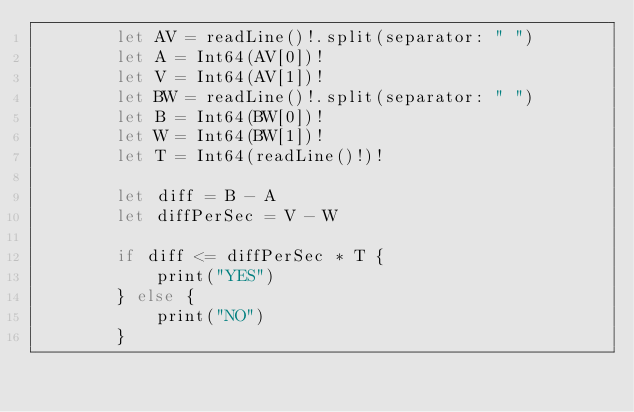<code> <loc_0><loc_0><loc_500><loc_500><_Swift_>        let AV = readLine()!.split(separator: " ")
        let A = Int64(AV[0])!
        let V = Int64(AV[1])!
        let BW = readLine()!.split(separator: " ")
        let B = Int64(BW[0])!
        let W = Int64(BW[1])!
        let T = Int64(readLine()!)!

        let diff = B - A
        let diffPerSec = V - W

        if diff <= diffPerSec * T {
            print("YES")
        } else {
            print("NO")
        }</code> 